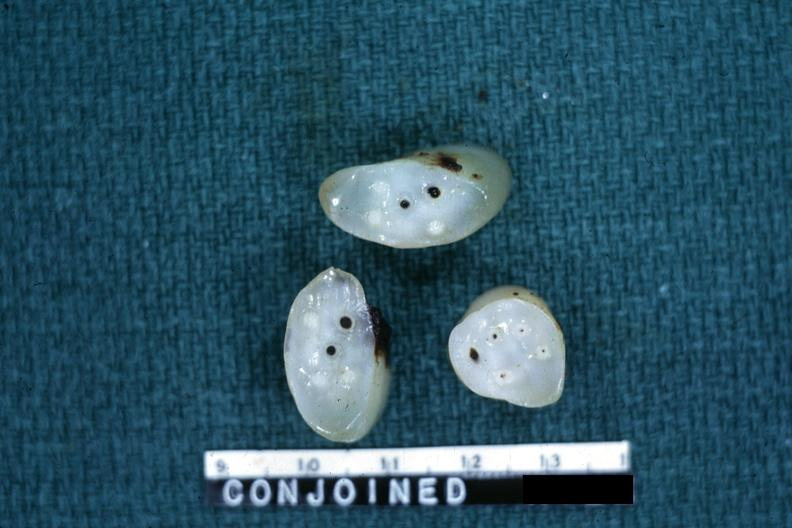what does this image show?
Answer the question using a single word or phrase. Cross sections showing apparently four arteries and two veins 